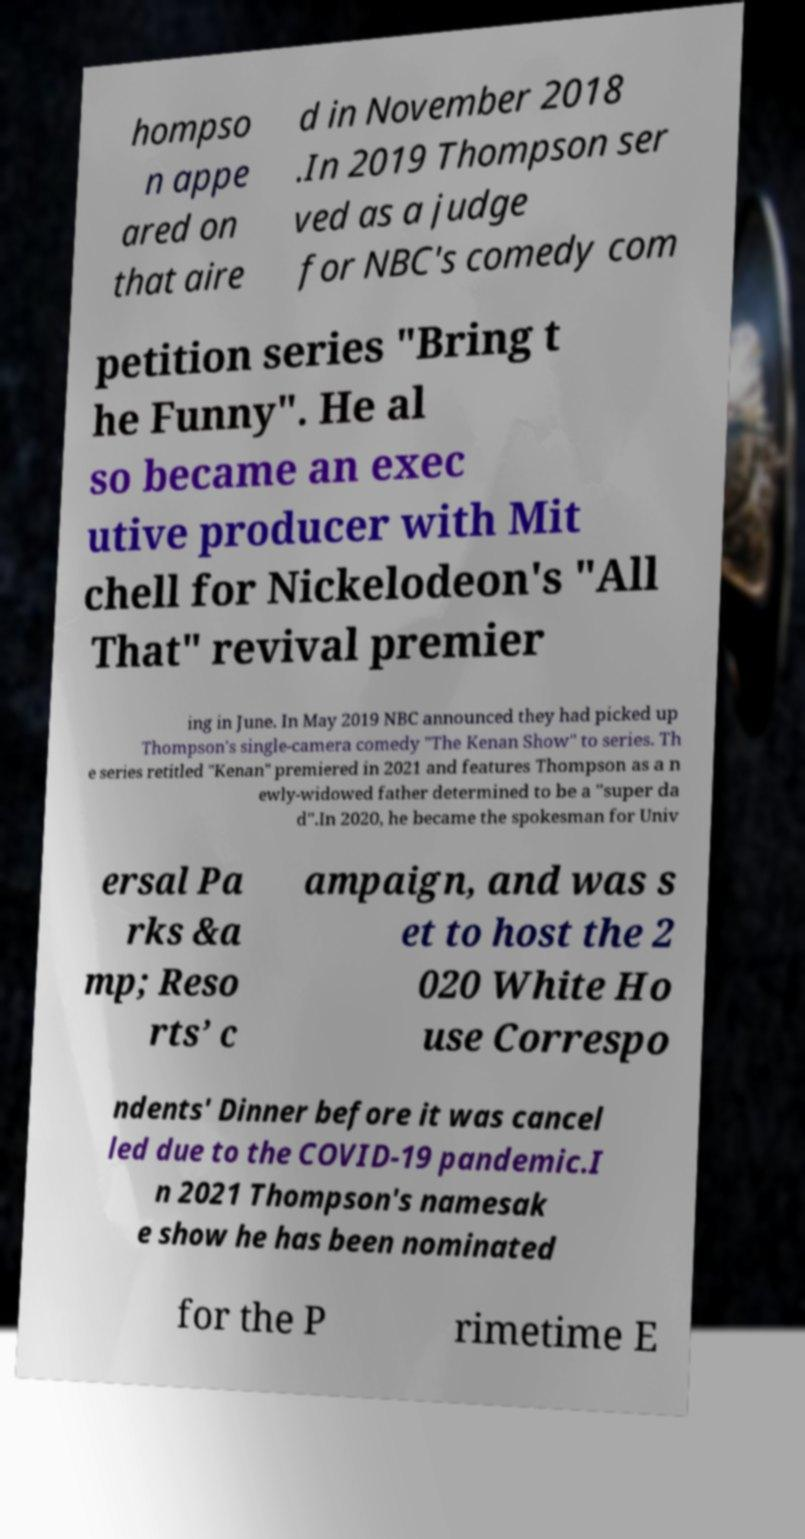Could you extract and type out the text from this image? hompso n appe ared on that aire d in November 2018 .In 2019 Thompson ser ved as a judge for NBC's comedy com petition series "Bring t he Funny". He al so became an exec utive producer with Mit chell for Nickelodeon's "All That" revival premier ing in June. In May 2019 NBC announced they had picked up Thompson's single-camera comedy "The Kenan Show" to series. Th e series retitled "Kenan" premiered in 2021 and features Thompson as a n ewly-widowed father determined to be a "super da d".In 2020, he became the spokesman for Univ ersal Pa rks &a mp; Reso rts’ c ampaign, and was s et to host the 2 020 White Ho use Correspo ndents' Dinner before it was cancel led due to the COVID-19 pandemic.I n 2021 Thompson's namesak e show he has been nominated for the P rimetime E 